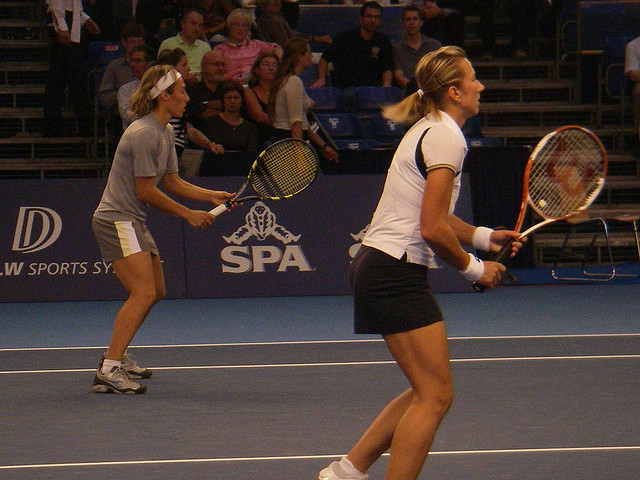Can you describe their attire? Both tennis players are dressed in sporty attire appropriate for a match. The player in the foreground is wearing a white top and skirt, with her hair tied back. The player in the background is wearing a light-colored shirt and shorts, complemented by a headband. 